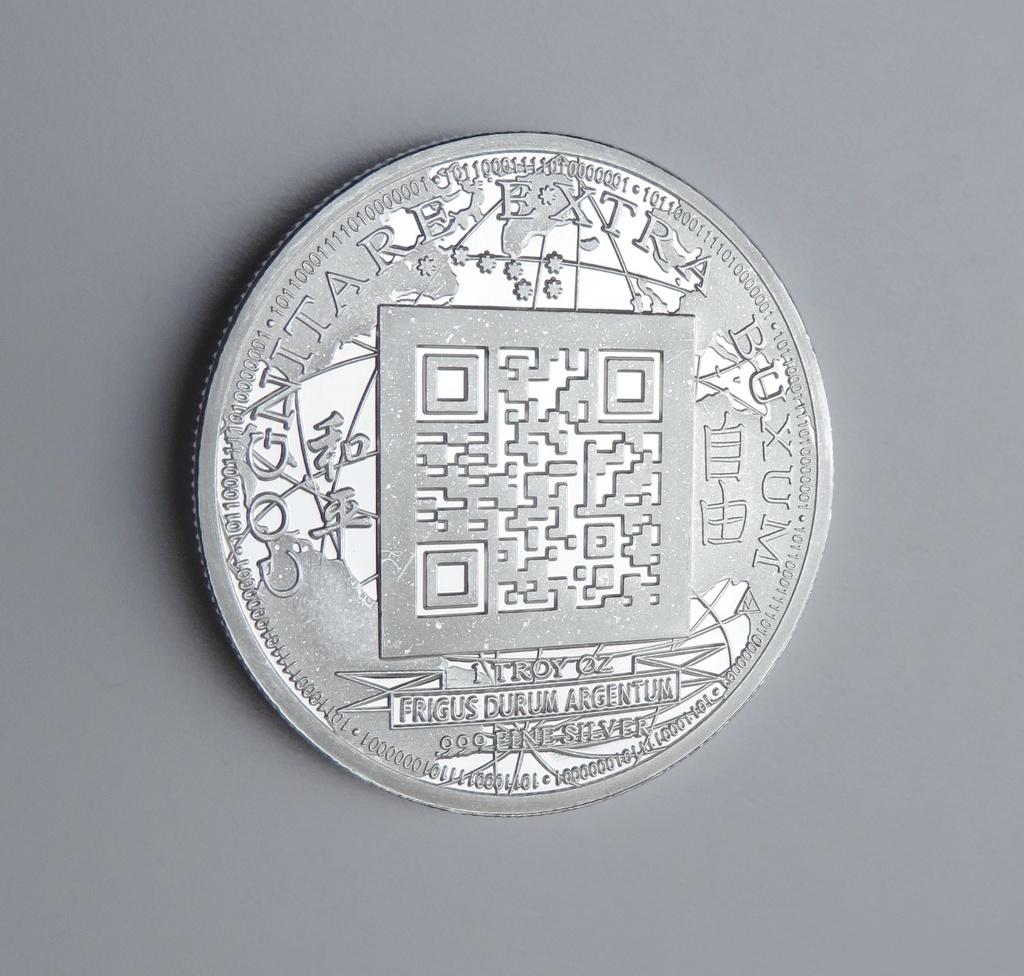What inscription is on the coin?
Provide a short and direct response. Frigus durum argentum. Is this written in upper or lower case?
Provide a short and direct response. Upper. 